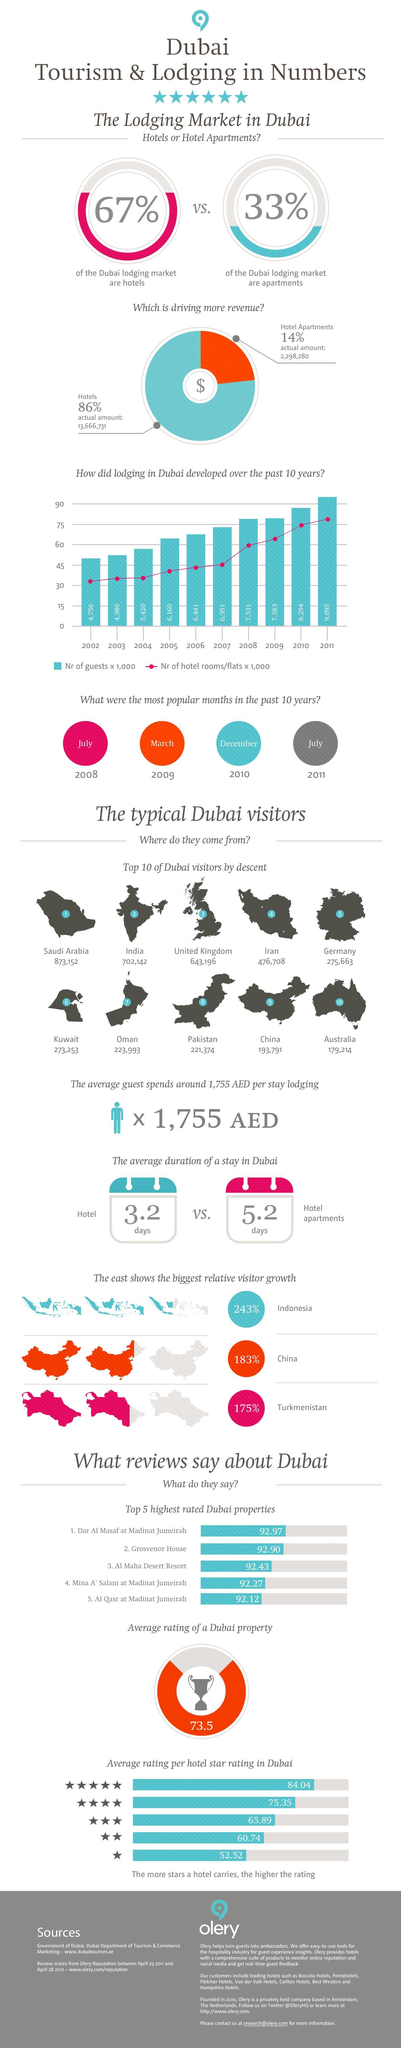What is the number of visitors from India?
Answer the question with a short phrase. 702,142 What is the number of visitors from Oman? 223,993 What percentage of the Dubai lodging market are apartments? 33% What percentage of the Dubai lodging market are hotels? 67% What is the number of visitors from Iran? 476,708 Which has the highest share-hotel apartments, hotels? hotels 